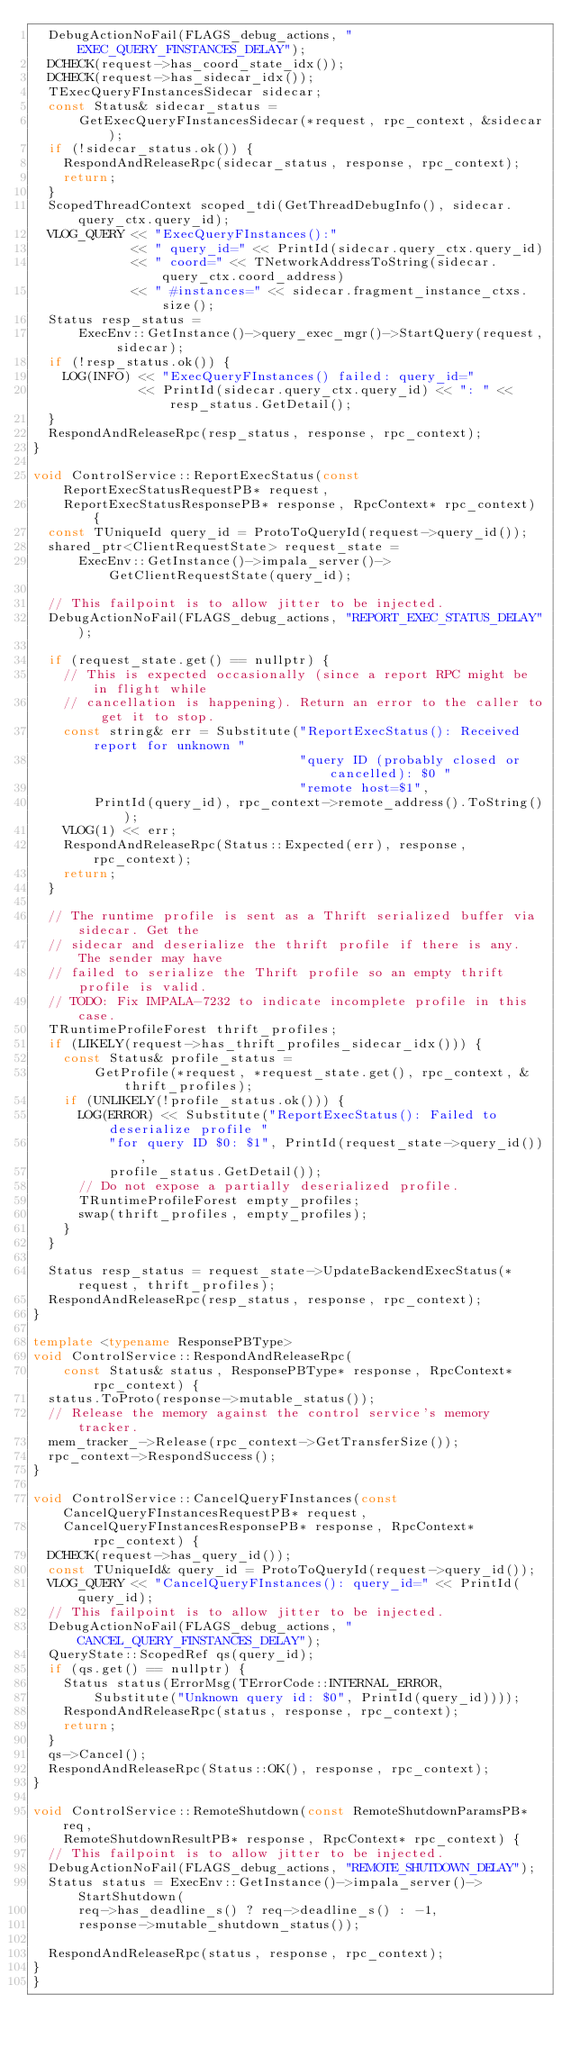<code> <loc_0><loc_0><loc_500><loc_500><_C++_>  DebugActionNoFail(FLAGS_debug_actions, "EXEC_QUERY_FINSTANCES_DELAY");
  DCHECK(request->has_coord_state_idx());
  DCHECK(request->has_sidecar_idx());
  TExecQueryFInstancesSidecar sidecar;
  const Status& sidecar_status =
      GetExecQueryFInstancesSidecar(*request, rpc_context, &sidecar);
  if (!sidecar_status.ok()) {
    RespondAndReleaseRpc(sidecar_status, response, rpc_context);
    return;
  }
  ScopedThreadContext scoped_tdi(GetThreadDebugInfo(), sidecar.query_ctx.query_id);
  VLOG_QUERY << "ExecQueryFInstances():"
             << " query_id=" << PrintId(sidecar.query_ctx.query_id)
             << " coord=" << TNetworkAddressToString(sidecar.query_ctx.coord_address)
             << " #instances=" << sidecar.fragment_instance_ctxs.size();
  Status resp_status =
      ExecEnv::GetInstance()->query_exec_mgr()->StartQuery(request, sidecar);
  if (!resp_status.ok()) {
    LOG(INFO) << "ExecQueryFInstances() failed: query_id="
              << PrintId(sidecar.query_ctx.query_id) << ": " << resp_status.GetDetail();
  }
  RespondAndReleaseRpc(resp_status, response, rpc_context);
}

void ControlService::ReportExecStatus(const ReportExecStatusRequestPB* request,
    ReportExecStatusResponsePB* response, RpcContext* rpc_context) {
  const TUniqueId query_id = ProtoToQueryId(request->query_id());
  shared_ptr<ClientRequestState> request_state =
      ExecEnv::GetInstance()->impala_server()->GetClientRequestState(query_id);

  // This failpoint is to allow jitter to be injected.
  DebugActionNoFail(FLAGS_debug_actions, "REPORT_EXEC_STATUS_DELAY");

  if (request_state.get() == nullptr) {
    // This is expected occasionally (since a report RPC might be in flight while
    // cancellation is happening). Return an error to the caller to get it to stop.
    const string& err = Substitute("ReportExecStatus(): Received report for unknown "
                                   "query ID (probably closed or cancelled): $0 "
                                   "remote host=$1",
        PrintId(query_id), rpc_context->remote_address().ToString());
    VLOG(1) << err;
    RespondAndReleaseRpc(Status::Expected(err), response, rpc_context);
    return;
  }

  // The runtime profile is sent as a Thrift serialized buffer via sidecar. Get the
  // sidecar and deserialize the thrift profile if there is any. The sender may have
  // failed to serialize the Thrift profile so an empty thrift profile is valid.
  // TODO: Fix IMPALA-7232 to indicate incomplete profile in this case.
  TRuntimeProfileForest thrift_profiles;
  if (LIKELY(request->has_thrift_profiles_sidecar_idx())) {
    const Status& profile_status =
        GetProfile(*request, *request_state.get(), rpc_context, &thrift_profiles);
    if (UNLIKELY(!profile_status.ok())) {
      LOG(ERROR) << Substitute("ReportExecStatus(): Failed to deserialize profile "
          "for query ID $0: $1", PrintId(request_state->query_id()),
          profile_status.GetDetail());
      // Do not expose a partially deserialized profile.
      TRuntimeProfileForest empty_profiles;
      swap(thrift_profiles, empty_profiles);
    }
  }

  Status resp_status = request_state->UpdateBackendExecStatus(*request, thrift_profiles);
  RespondAndReleaseRpc(resp_status, response, rpc_context);
}

template <typename ResponsePBType>
void ControlService::RespondAndReleaseRpc(
    const Status& status, ResponsePBType* response, RpcContext* rpc_context) {
  status.ToProto(response->mutable_status());
  // Release the memory against the control service's memory tracker.
  mem_tracker_->Release(rpc_context->GetTransferSize());
  rpc_context->RespondSuccess();
}

void ControlService::CancelQueryFInstances(const CancelQueryFInstancesRequestPB* request,
    CancelQueryFInstancesResponsePB* response, RpcContext* rpc_context) {
  DCHECK(request->has_query_id());
  const TUniqueId& query_id = ProtoToQueryId(request->query_id());
  VLOG_QUERY << "CancelQueryFInstances(): query_id=" << PrintId(query_id);
  // This failpoint is to allow jitter to be injected.
  DebugActionNoFail(FLAGS_debug_actions, "CANCEL_QUERY_FINSTANCES_DELAY");
  QueryState::ScopedRef qs(query_id);
  if (qs.get() == nullptr) {
    Status status(ErrorMsg(TErrorCode::INTERNAL_ERROR,
        Substitute("Unknown query id: $0", PrintId(query_id))));
    RespondAndReleaseRpc(status, response, rpc_context);
    return;
  }
  qs->Cancel();
  RespondAndReleaseRpc(Status::OK(), response, rpc_context);
}

void ControlService::RemoteShutdown(const RemoteShutdownParamsPB* req,
    RemoteShutdownResultPB* response, RpcContext* rpc_context) {
  // This failpoint is to allow jitter to be injected.
  DebugActionNoFail(FLAGS_debug_actions, "REMOTE_SHUTDOWN_DELAY");
  Status status = ExecEnv::GetInstance()->impala_server()->StartShutdown(
      req->has_deadline_s() ? req->deadline_s() : -1,
      response->mutable_shutdown_status());

  RespondAndReleaseRpc(status, response, rpc_context);
}
}
</code> 